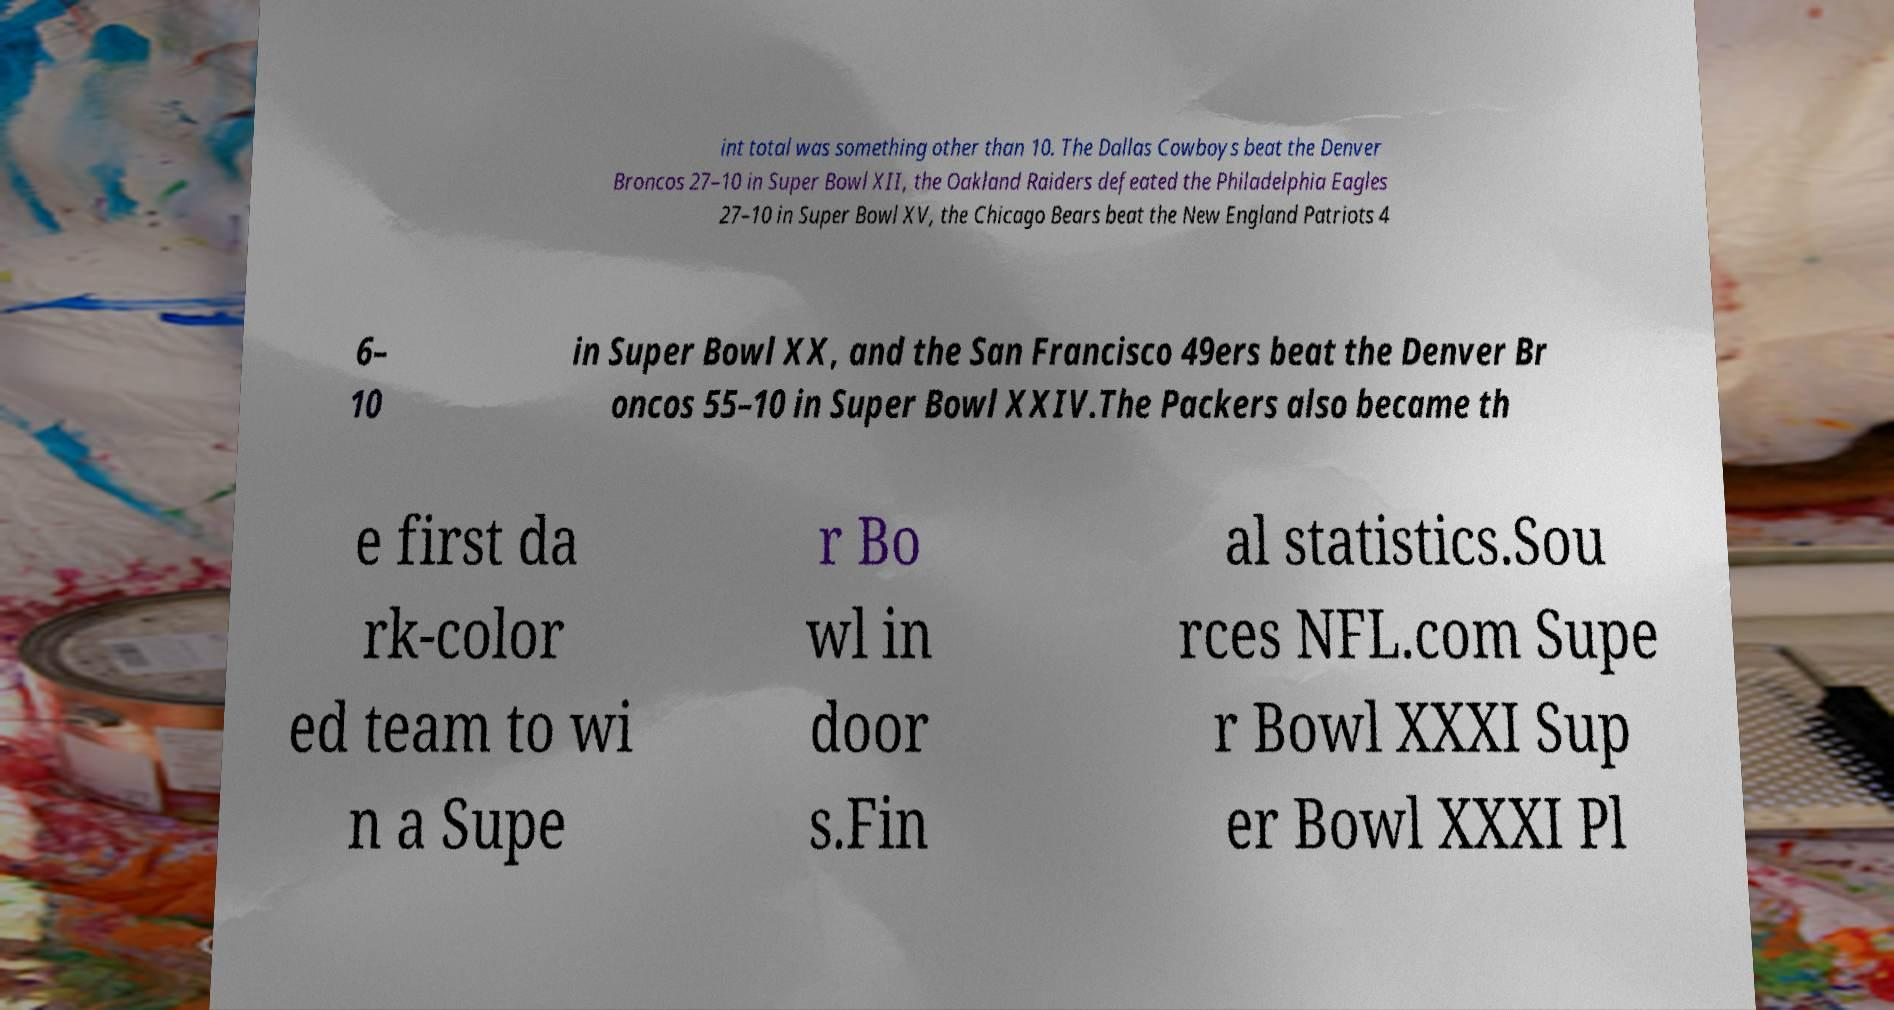Can you accurately transcribe the text from the provided image for me? int total was something other than 10. The Dallas Cowboys beat the Denver Broncos 27–10 in Super Bowl XII, the Oakland Raiders defeated the Philadelphia Eagles 27–10 in Super Bowl XV, the Chicago Bears beat the New England Patriots 4 6– 10 in Super Bowl XX, and the San Francisco 49ers beat the Denver Br oncos 55–10 in Super Bowl XXIV.The Packers also became th e first da rk-color ed team to wi n a Supe r Bo wl in door s.Fin al statistics.Sou rces NFL.com Supe r Bowl XXXI Sup er Bowl XXXI Pl 